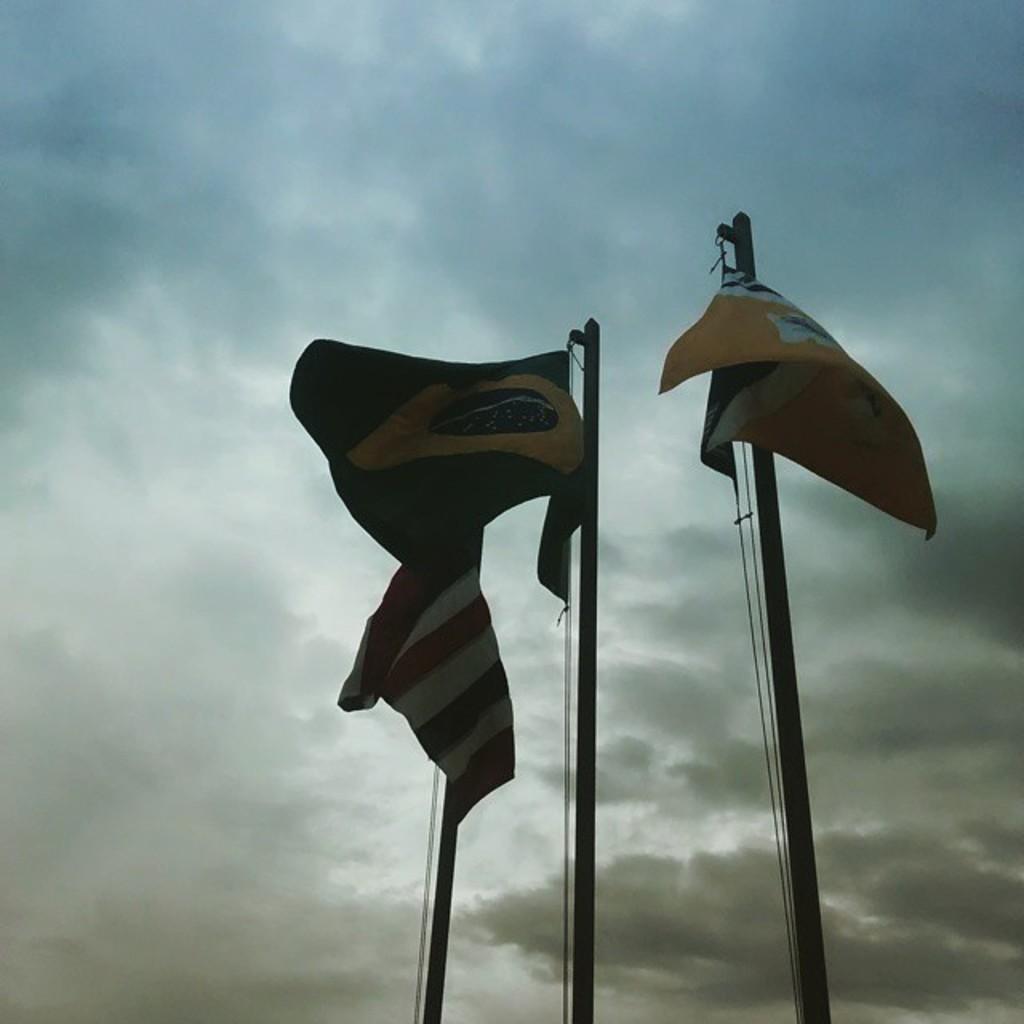Could you give a brief overview of what you see in this image? We can see flags on poles. In the background we can see sky with clouds. 